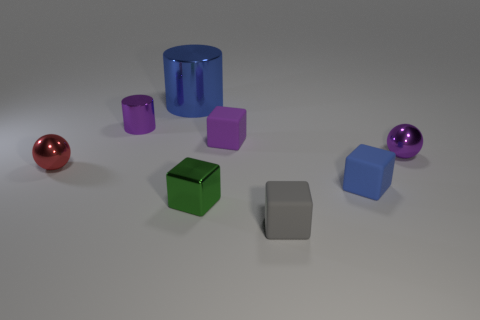Subtract 1 cubes. How many cubes are left? 3 Add 2 large metal objects. How many objects exist? 10 Subtract all cylinders. How many objects are left? 6 Add 6 large green rubber blocks. How many large green rubber blocks exist? 6 Subtract 0 brown balls. How many objects are left? 8 Subtract all large purple metallic balls. Subtract all green objects. How many objects are left? 7 Add 3 gray cubes. How many gray cubes are left? 4 